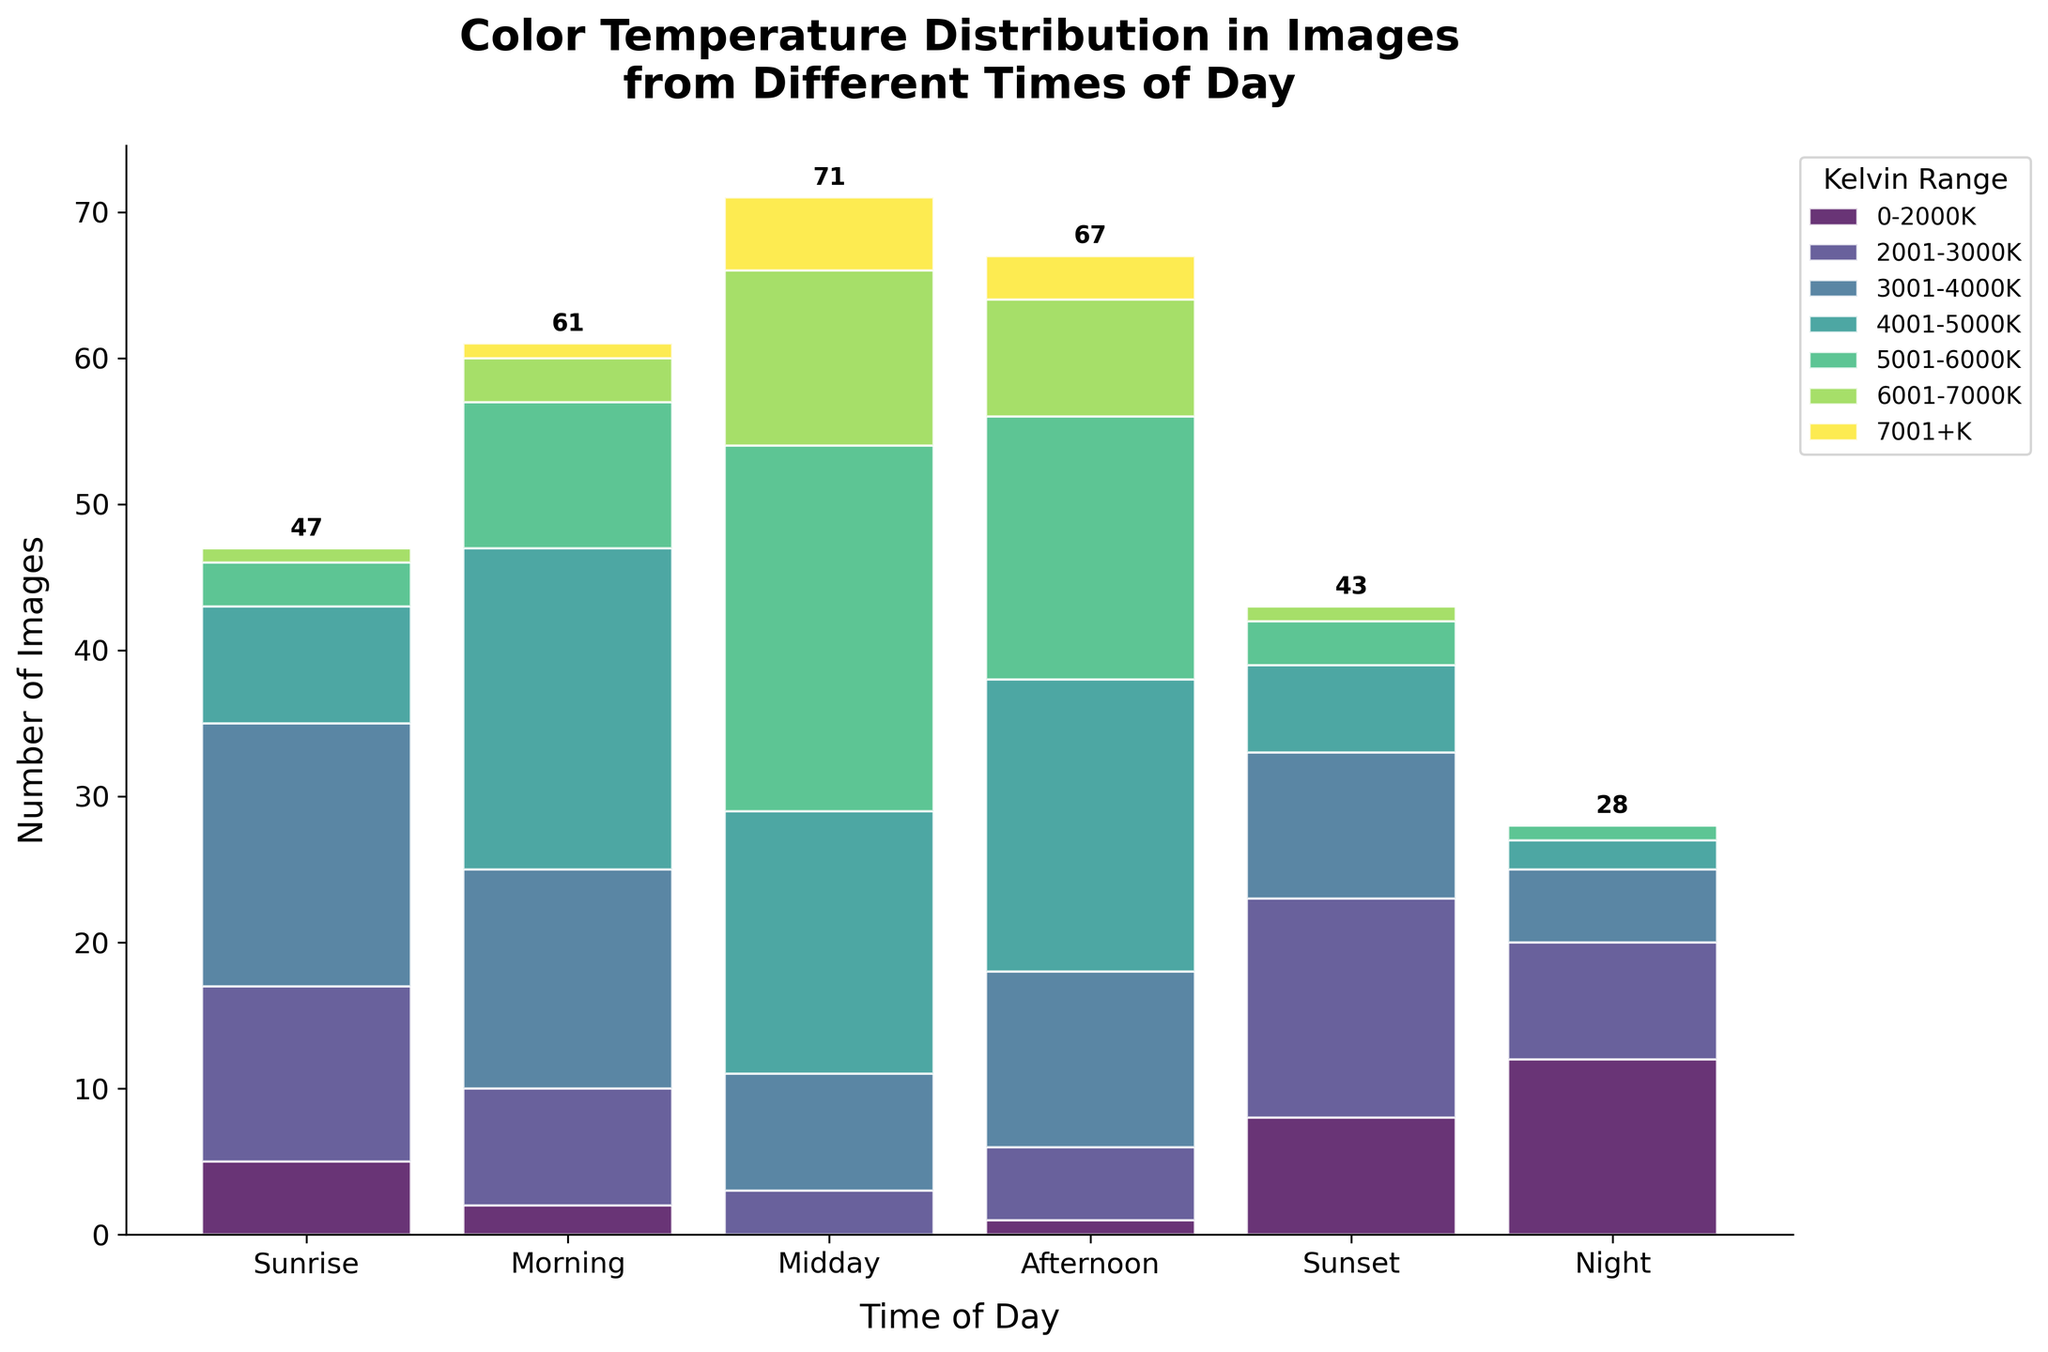Can you tell me the title of the figure? The title is displayed at the top of the figure in large, bold font. It reads "Color Temperature Distribution in Images from Different Times of Day."
Answer: Color Temperature Distribution in Images from Different Times of Day Which Kelvin range has the highest number of images at Midday? To find this, look at the Midday bar and identify the section that is the largest. The 5001-6000K range is the tallest section in the Midday bar.
Answer: 5001-6000K How many total images were taken at Sunrise? Sum up the values for all Kelvin ranges at Sunrise: 5 + 12 + 18 + 8 + 3 + 1 + 0 = 47.
Answer: 47 During which time of day were the most images taken in the 3001-4000K range? Observe the 3001-4000K section across all bars. The tallest one is during Sunrise at 18 images.
Answer: Sunrise Compare the number of images taken at Night with different Kelvin ranges. Which Kelvin range had the fewest images? Look at the Night bar and find the smallest section. The histogram shows zero images for the 7001+K range at Night.
Answer: 7001+K How does the number of images in the 2001-3000K range at Morning compare to those at Sunset? Examine the bars for Morning and Sunset in the 2001-3000K range. Morning has 8 images and Sunset has 15 images. Sunset has more images in this range.
Answer: Sunset What is the sum of images taken at Midday and Afternoon in the 6001-7000K range? Sum the values for 6001-7000K at both times: 12 (Midday) + 8 (Afternoon) = 20.
Answer: 20 How many more images were taken at Night compared to Midday? Calculate the total number of images taken at both times. For Night: 12 + 8 + 5 + 2 + 1 + 0 + 0 = 28. For Midday: 0 + 3 + 8 + 18 + 25 + 12 + 5 = 71. The difference is 71 - 28 = 43.
Answer: 43 Which time of day has the second highest total number of images? Sum up the total images for each time of day. 
- Sunrise: 47
- Morning: 61
- Midday: 71
- Afternoon: 67
- Sunset: 43
- Night: 28
The second highest is Afternoon with 67 images.
Answer: Afternoon In which Kelvin range do we see an increase in the number of images from Sunrise to Morning? Compare the values for each Kelvin range from Sunrise to Morning:
- 0-2000K: 5 to 2 (decrease) 
- 2001-3000K: 12 to 8 (decrease)
- 3001-4000K: 18 to 15 (decrease)
- 4001-5000K: 8 to 22 (increase)
- 5001-6000K: 3 to 10 (increase)
- 6001-7000K: 1 to 3 (increase)
- 7001+K: 0 to 1 (increase)
We see an increase in the 4001-5000K, 5001-6000K, 6001-7000K, and 7001+K ranges.
Answer: 4001-5000K, 5001-6000K, 6001-7000K, 7001+K 